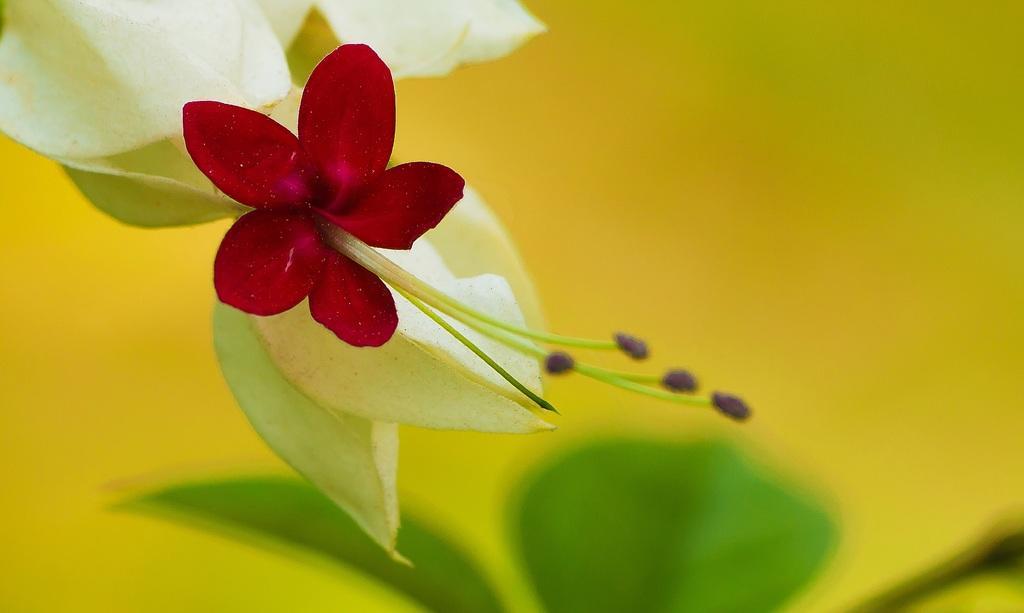Can you describe this image briefly? This image consists of a flower. It is in red color. There are leaves in this image. 